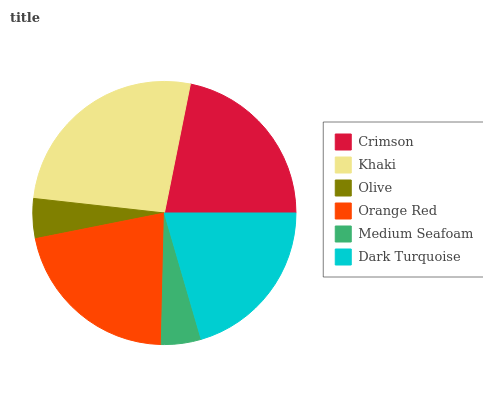Is Olive the minimum?
Answer yes or no. Yes. Is Khaki the maximum?
Answer yes or no. Yes. Is Khaki the minimum?
Answer yes or no. No. Is Olive the maximum?
Answer yes or no. No. Is Khaki greater than Olive?
Answer yes or no. Yes. Is Olive less than Khaki?
Answer yes or no. Yes. Is Olive greater than Khaki?
Answer yes or no. No. Is Khaki less than Olive?
Answer yes or no. No. Is Orange Red the high median?
Answer yes or no. Yes. Is Dark Turquoise the low median?
Answer yes or no. Yes. Is Crimson the high median?
Answer yes or no. No. Is Crimson the low median?
Answer yes or no. No. 